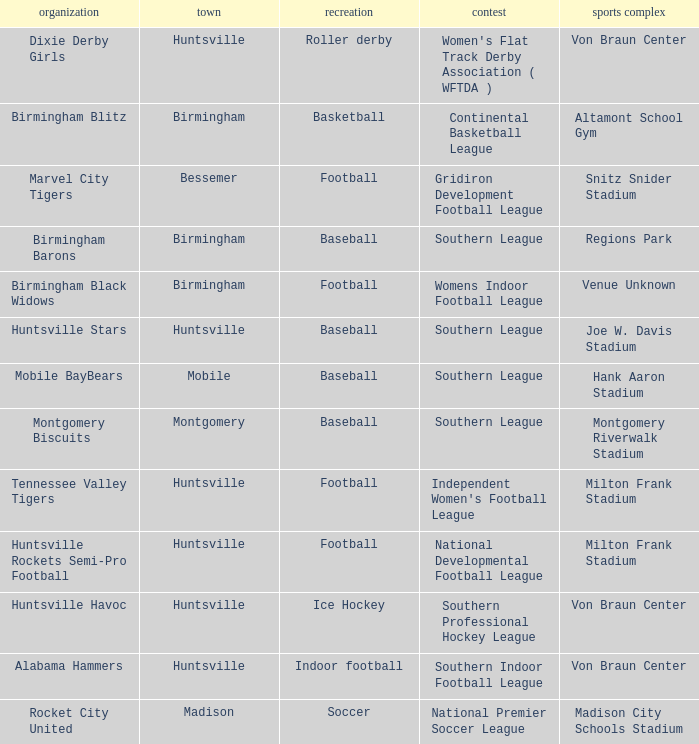Which sport was held in Huntsville at the Von Braun Center as part of the Southern Indoor Football League? Indoor football. Could you help me parse every detail presented in this table? {'header': ['organization', 'town', 'recreation', 'contest', 'sports complex'], 'rows': [['Dixie Derby Girls', 'Huntsville', 'Roller derby', "Women's Flat Track Derby Association ( WFTDA )", 'Von Braun Center'], ['Birmingham Blitz', 'Birmingham', 'Basketball', 'Continental Basketball League', 'Altamont School Gym'], ['Marvel City Tigers', 'Bessemer', 'Football', 'Gridiron Development Football League', 'Snitz Snider Stadium'], ['Birmingham Barons', 'Birmingham', 'Baseball', 'Southern League', 'Regions Park'], ['Birmingham Black Widows', 'Birmingham', 'Football', 'Womens Indoor Football League', 'Venue Unknown'], ['Huntsville Stars', 'Huntsville', 'Baseball', 'Southern League', 'Joe W. Davis Stadium'], ['Mobile BayBears', 'Mobile', 'Baseball', 'Southern League', 'Hank Aaron Stadium'], ['Montgomery Biscuits', 'Montgomery', 'Baseball', 'Southern League', 'Montgomery Riverwalk Stadium'], ['Tennessee Valley Tigers', 'Huntsville', 'Football', "Independent Women's Football League", 'Milton Frank Stadium'], ['Huntsville Rockets Semi-Pro Football', 'Huntsville', 'Football', 'National Developmental Football League', 'Milton Frank Stadium'], ['Huntsville Havoc', 'Huntsville', 'Ice Hockey', 'Southern Professional Hockey League', 'Von Braun Center'], ['Alabama Hammers', 'Huntsville', 'Indoor football', 'Southern Indoor Football League', 'Von Braun Center'], ['Rocket City United', 'Madison', 'Soccer', 'National Premier Soccer League', 'Madison City Schools Stadium']]} 